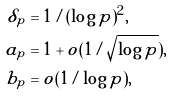<formula> <loc_0><loc_0><loc_500><loc_500>\delta _ { p } & = 1 / ( \log p ) ^ { 2 } , \\ a _ { p } & = 1 + o ( 1 / \sqrt { \log p } ) , \\ b _ { p } & = o ( 1 / \log p ) ,</formula> 